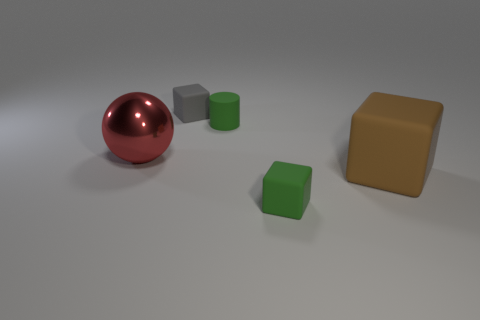There is a matte thing that is the same color as the cylinder; what size is it?
Provide a succinct answer. Small. What is the material of the gray object?
Your answer should be very brief. Rubber. Are the gray block and the large object that is right of the red ball made of the same material?
Keep it short and to the point. Yes. What color is the big thing that is to the right of the green matte object in front of the brown rubber block?
Offer a very short reply. Brown. What is the size of the object that is both left of the cylinder and right of the big metallic sphere?
Your response must be concise. Small. How many other things are there of the same shape as the red metallic thing?
Your response must be concise. 0. There is a large brown rubber thing; is its shape the same as the green thing that is in front of the red thing?
Keep it short and to the point. Yes. How many tiny green matte objects are behind the big brown rubber block?
Ensure brevity in your answer.  1. Is there anything else that has the same material as the red sphere?
Offer a very short reply. No. Does the tiny green object that is behind the large rubber block have the same shape as the large red thing?
Your answer should be very brief. No. 